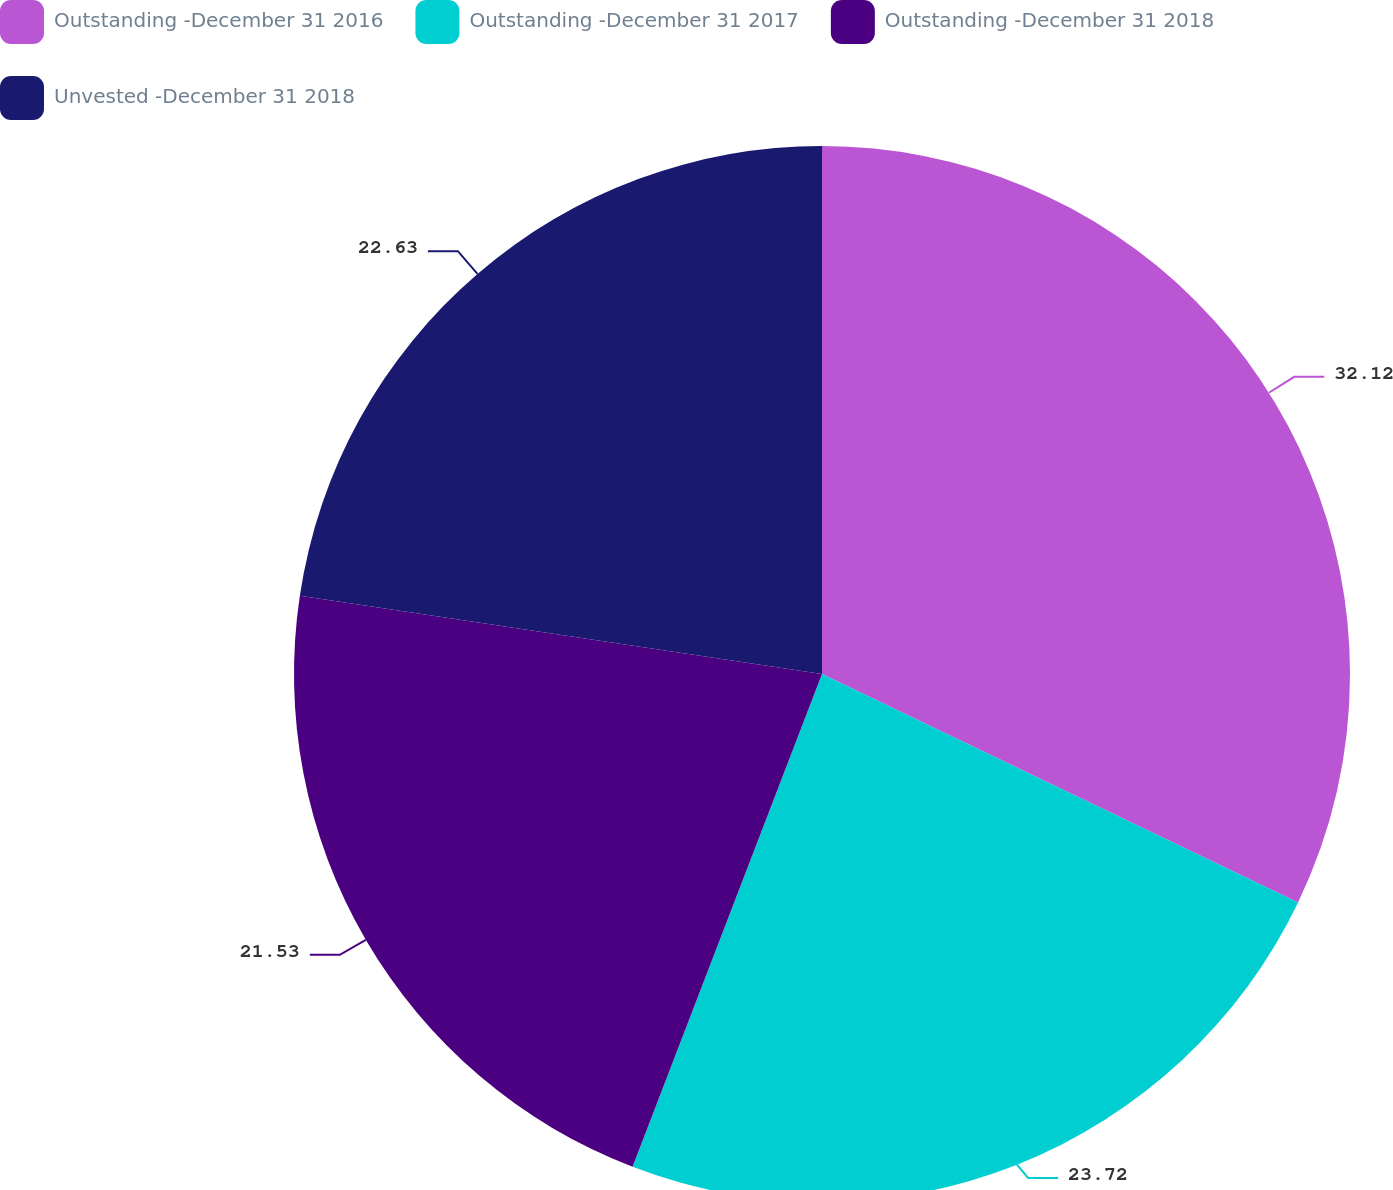Convert chart to OTSL. <chart><loc_0><loc_0><loc_500><loc_500><pie_chart><fcel>Outstanding -December 31 2016<fcel>Outstanding -December 31 2017<fcel>Outstanding -December 31 2018<fcel>Unvested -December 31 2018<nl><fcel>32.12%<fcel>23.72%<fcel>21.53%<fcel>22.63%<nl></chart> 